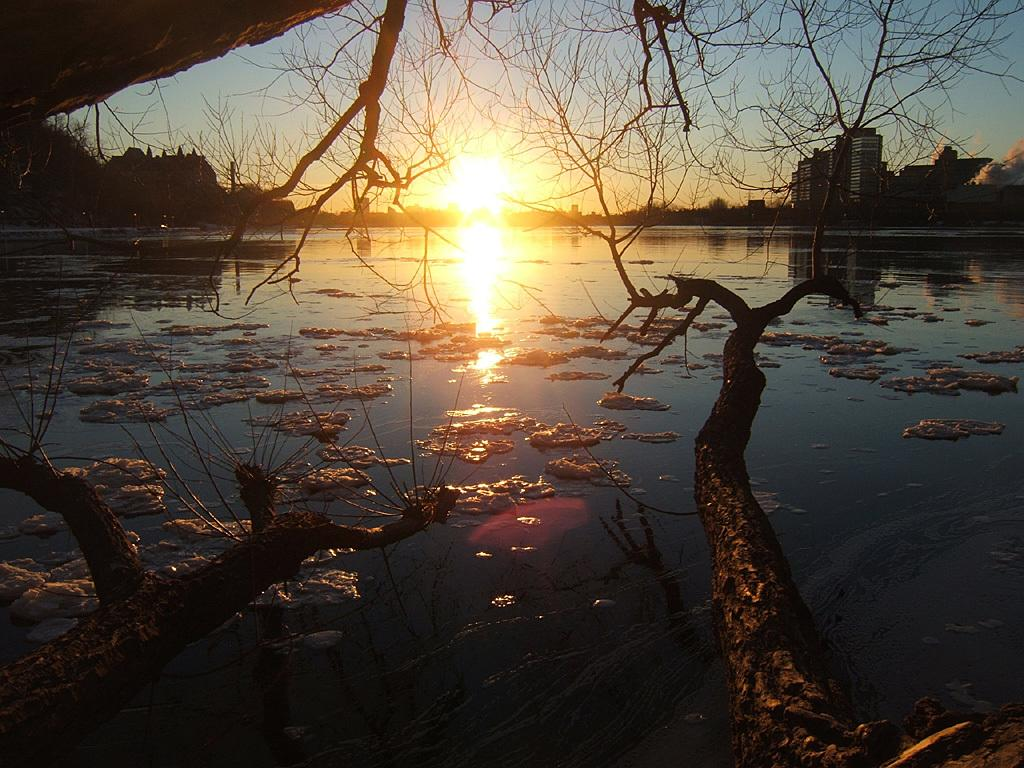What is in front of the image? There are trees in front of the image. What is on the water in the image? There is snow on the water. What can be seen in the background of the image? There are buildings and trees in the background of the image. What is visible in the sky at the top of the image? The sun is visible in the sky at the top of the image. How many rabbits are sitting on the stem of the tree in the image? There are no rabbits or stems present in the image. What type of boats can be seen sailing in the water in the image? There are no boats visible in the image; it features snow on the water. 